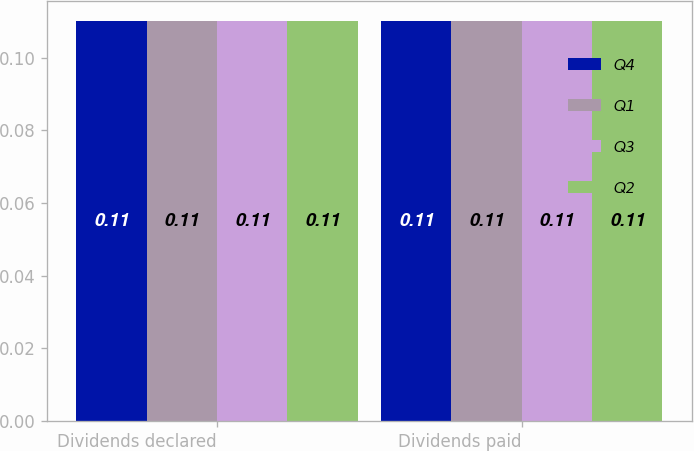Convert chart to OTSL. <chart><loc_0><loc_0><loc_500><loc_500><stacked_bar_chart><ecel><fcel>Dividends declared<fcel>Dividends paid<nl><fcel>Q4<fcel>0.11<fcel>0.11<nl><fcel>Q1<fcel>0.11<fcel>0.11<nl><fcel>Q3<fcel>0.11<fcel>0.11<nl><fcel>Q2<fcel>0.11<fcel>0.11<nl></chart> 